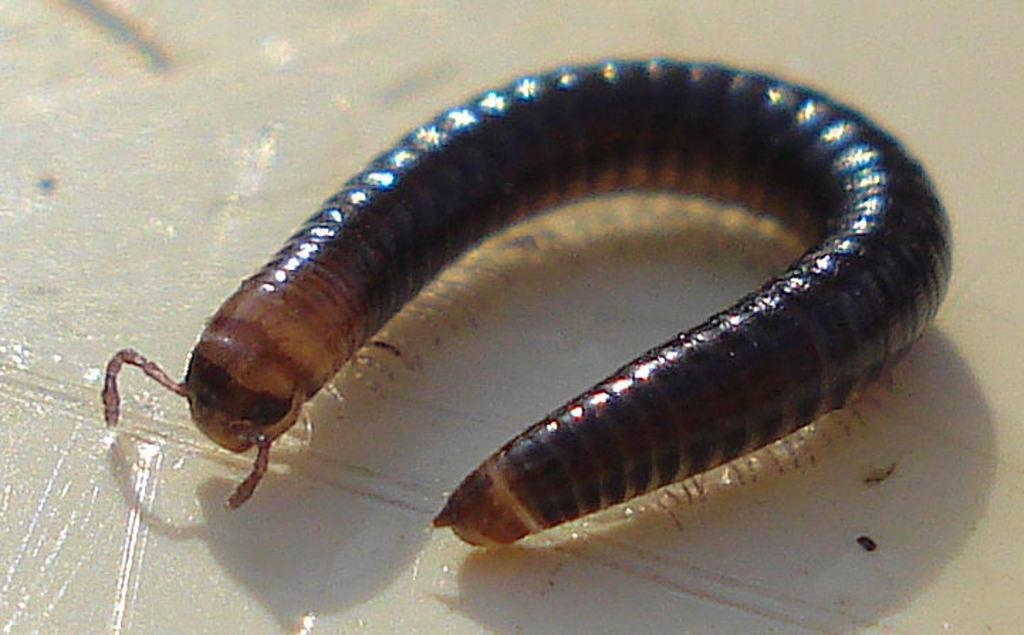What is the primary color of the surface in the image? The primary color of the surface in the image is white. What is present on the white surface? There is an insect on the white surface. Can you describe the appearance of the insect? The insect has a brown and black color. What type of order does the insect follow in the image? There is no indication of an order or any specific behavior in the image; it simply shows an insect on a white surface. 